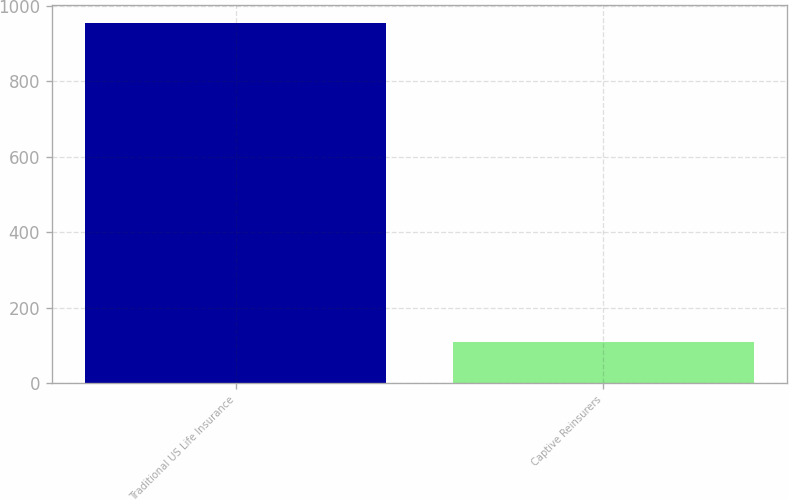<chart> <loc_0><loc_0><loc_500><loc_500><bar_chart><fcel>Traditional US Life Insurance<fcel>Captive Reinsurers<nl><fcel>953<fcel>109.6<nl></chart> 